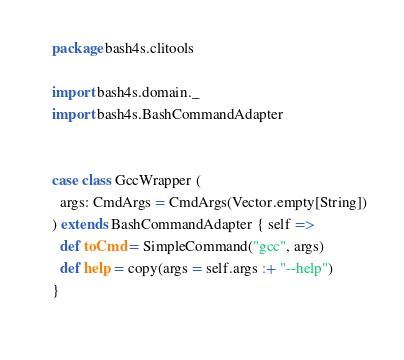<code> <loc_0><loc_0><loc_500><loc_500><_Scala_>
    package bash4s.clitools

    import bash4s.domain._
    import bash4s.BashCommandAdapter

    
    case class GccWrapper (
      args: CmdArgs = CmdArgs(Vector.empty[String])
    ) extends BashCommandAdapter { self =>
      def toCmd = SimpleCommand("gcc", args)
      def help = copy(args = self.args :+ "--help")
    }
    </code> 